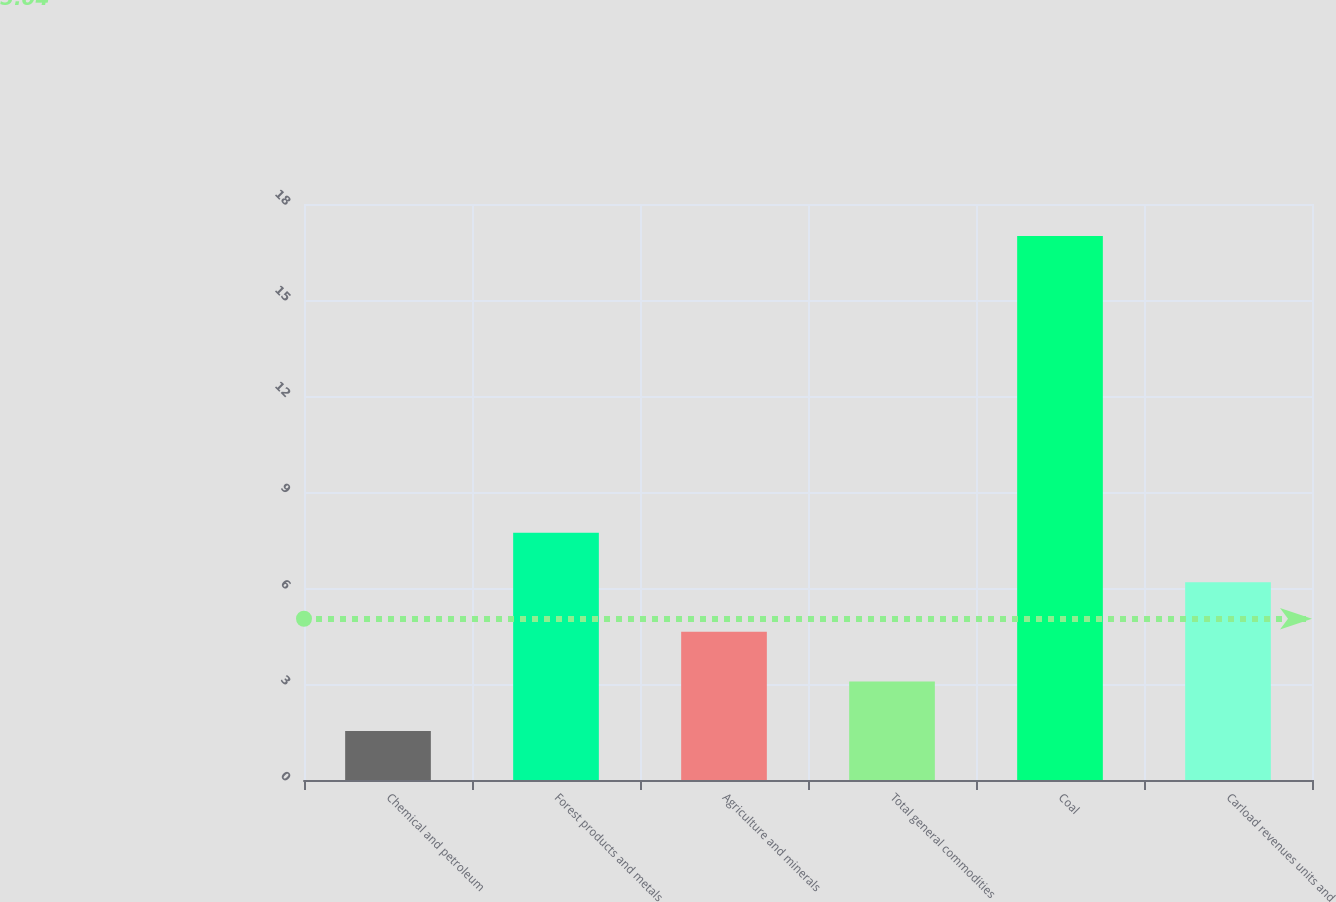<chart> <loc_0><loc_0><loc_500><loc_500><bar_chart><fcel>Chemical and petroleum<fcel>Forest products and metals<fcel>Agriculture and minerals<fcel>Total general commodities<fcel>Coal<fcel>Carload revenues units and<nl><fcel>1.53<fcel>7.73<fcel>4.63<fcel>3.08<fcel>17<fcel>6.18<nl></chart> 